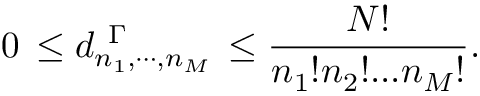<formula> <loc_0><loc_0><loc_500><loc_500>0 \, \leq d _ { n _ { 1 } , \cdots , n _ { M } } ^ { \ \Gamma } \, \leq \frac { N ! } { n _ { 1 } ! n _ { 2 } ! \dots n _ { M } ! } .</formula> 